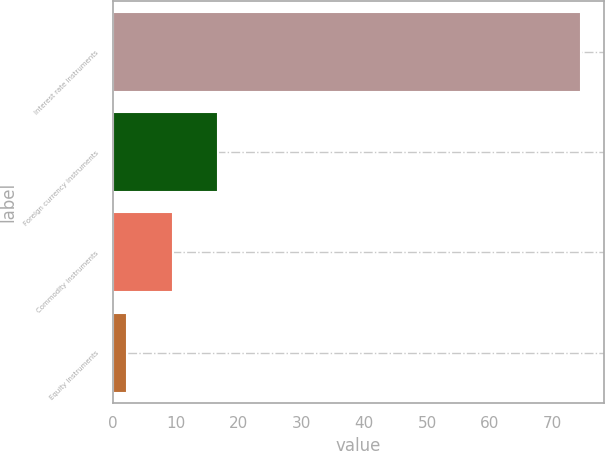<chart> <loc_0><loc_0><loc_500><loc_500><bar_chart><fcel>Interest rate instruments<fcel>Foreign currency instruments<fcel>Commodity instruments<fcel>Equity instruments<nl><fcel>74.4<fcel>16.8<fcel>9.51<fcel>2.3<nl></chart> 